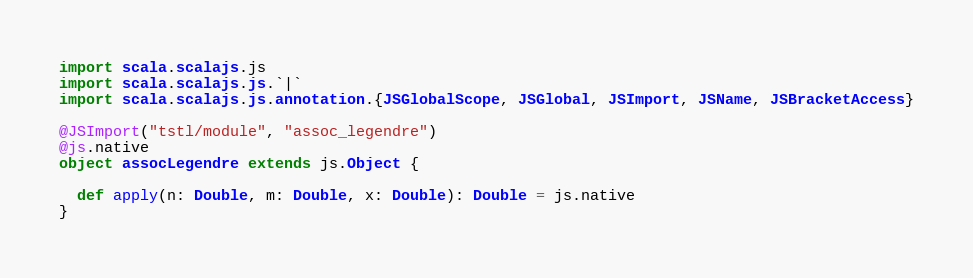<code> <loc_0><loc_0><loc_500><loc_500><_Scala_>import scala.scalajs.js
import scala.scalajs.js.`|`
import scala.scalajs.js.annotation.{JSGlobalScope, JSGlobal, JSImport, JSName, JSBracketAccess}

@JSImport("tstl/module", "assoc_legendre")
@js.native
object assocLegendre extends js.Object {
  
  def apply(n: Double, m: Double, x: Double): Double = js.native
}
</code> 